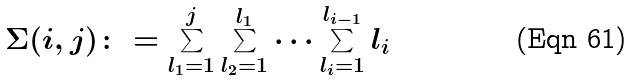<formula> <loc_0><loc_0><loc_500><loc_500>\Sigma ( i , j ) \colon = \sum _ { l _ { 1 } = 1 } ^ { j } \sum _ { l _ { 2 } = 1 } ^ { l _ { 1 } } \dots \sum _ { l _ { i } = 1 } ^ { l _ { i - 1 } } l _ { i }</formula> 